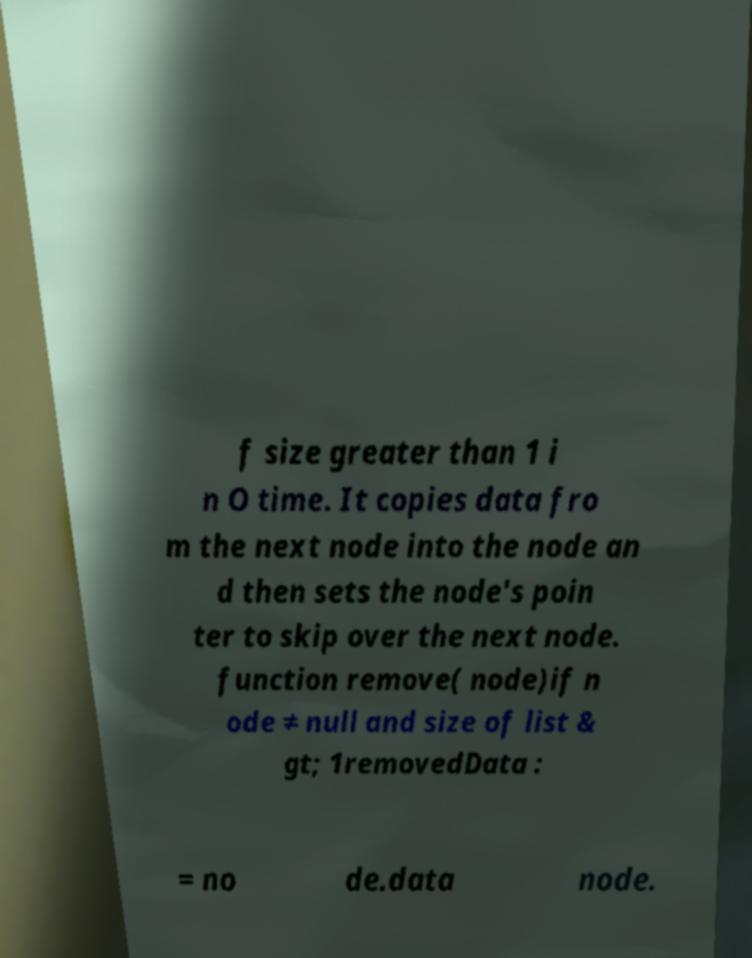For documentation purposes, I need the text within this image transcribed. Could you provide that? f size greater than 1 i n O time. It copies data fro m the next node into the node an d then sets the node's poin ter to skip over the next node. function remove( node)if n ode ≠ null and size of list & gt; 1removedData : = no de.data node. 